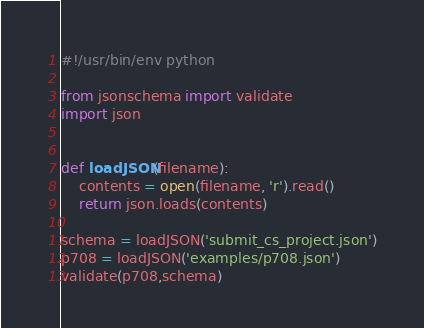Convert code to text. <code><loc_0><loc_0><loc_500><loc_500><_Python_>#!/usr/bin/env python

from jsonschema import validate
import json


def loadJSON(filename):
    contents = open(filename, 'r').read()
    return json.loads(contents)
    
schema = loadJSON('submit_cs_project.json')
p708 = loadJSON('examples/p708.json')
validate(p708,schema)

</code> 